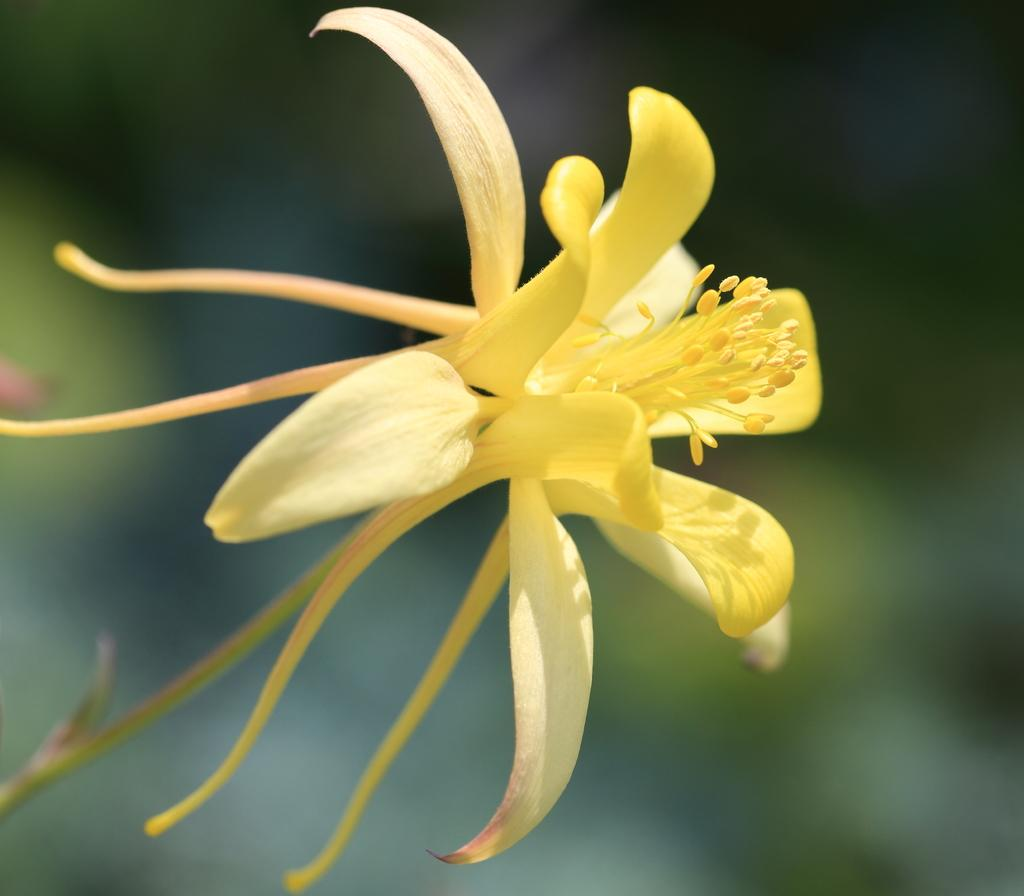What type of flower is present in the image? There is a yellow color flower in the image. Can you describe the background of the image? The background of the image is blurred. How many legs can be seen on the flower in the image? Flowers do not have legs, so there are no legs visible on the flower in the image. 